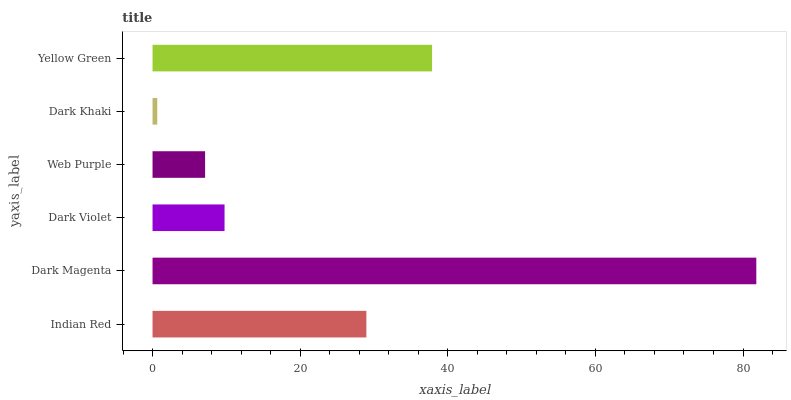Is Dark Khaki the minimum?
Answer yes or no. Yes. Is Dark Magenta the maximum?
Answer yes or no. Yes. Is Dark Violet the minimum?
Answer yes or no. No. Is Dark Violet the maximum?
Answer yes or no. No. Is Dark Magenta greater than Dark Violet?
Answer yes or no. Yes. Is Dark Violet less than Dark Magenta?
Answer yes or no. Yes. Is Dark Violet greater than Dark Magenta?
Answer yes or no. No. Is Dark Magenta less than Dark Violet?
Answer yes or no. No. Is Indian Red the high median?
Answer yes or no. Yes. Is Dark Violet the low median?
Answer yes or no. Yes. Is Dark Violet the high median?
Answer yes or no. No. Is Indian Red the low median?
Answer yes or no. No. 